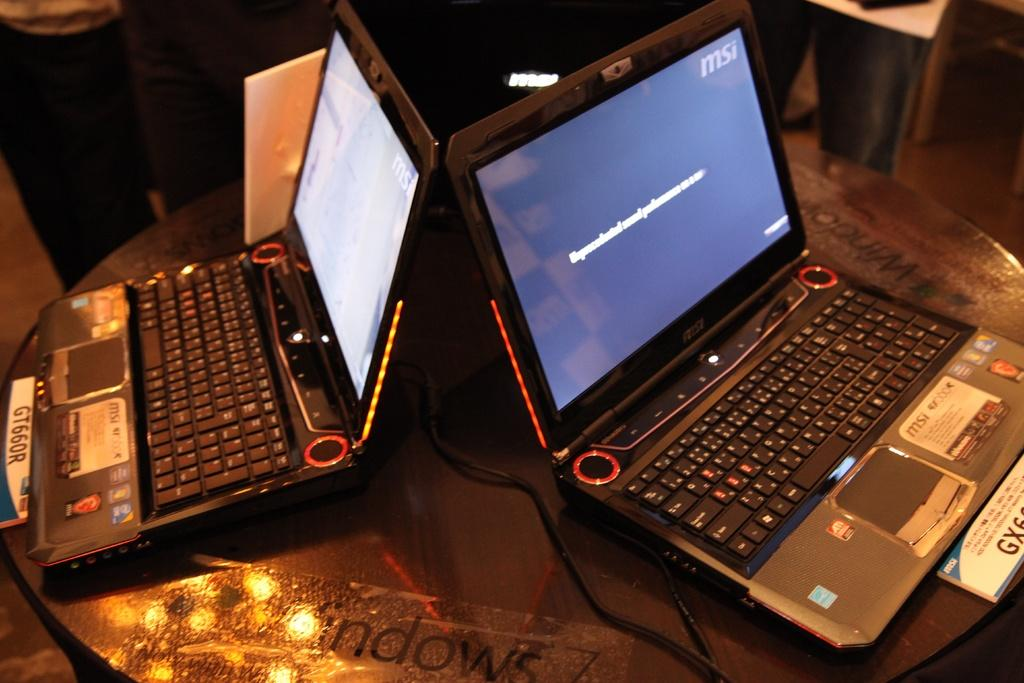Provide a one-sentence caption for the provided image. two laptops on a table, one of them has the letters MSI on. 